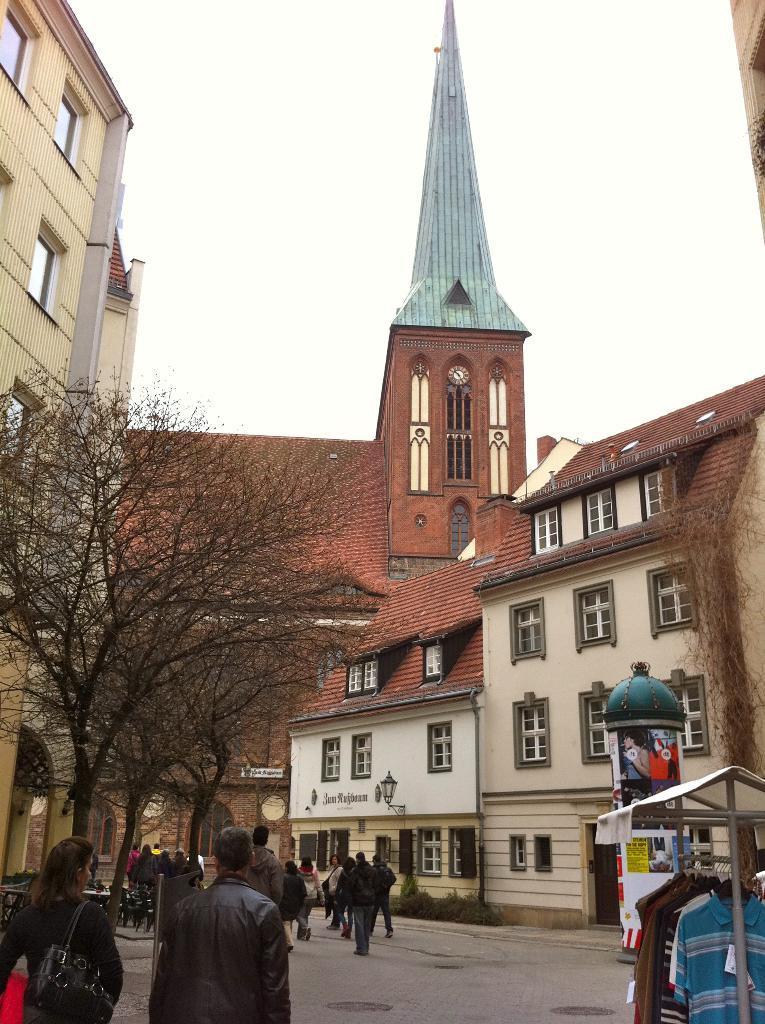Can you describe this image briefly? This is a picture of a city where there are group of people standing, buildings, trees, clothes on the cloth stand, and in the background there is sky. 